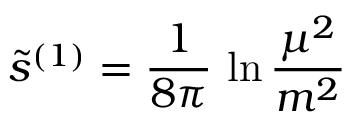<formula> <loc_0><loc_0><loc_500><loc_500>\tilde { s } ^ { ( 1 ) } = { \frac { 1 } { 8 \pi } } \, \ln { \frac { \mu ^ { 2 } } { m ^ { 2 } } }</formula> 